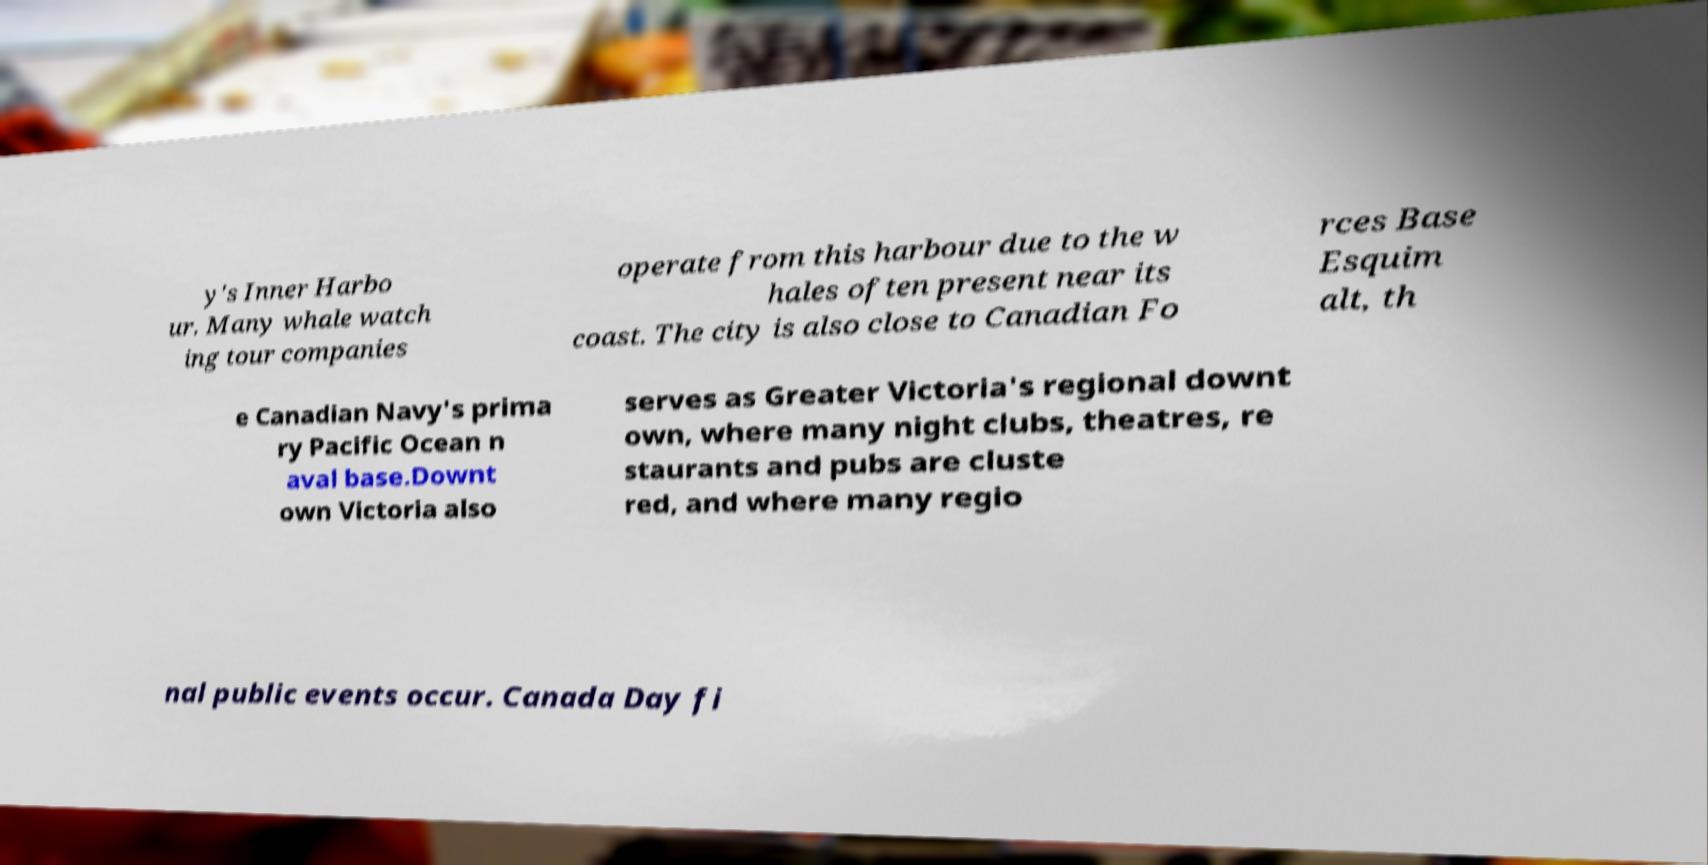I need the written content from this picture converted into text. Can you do that? y's Inner Harbo ur. Many whale watch ing tour companies operate from this harbour due to the w hales often present near its coast. The city is also close to Canadian Fo rces Base Esquim alt, th e Canadian Navy's prima ry Pacific Ocean n aval base.Downt own Victoria also serves as Greater Victoria's regional downt own, where many night clubs, theatres, re staurants and pubs are cluste red, and where many regio nal public events occur. Canada Day fi 